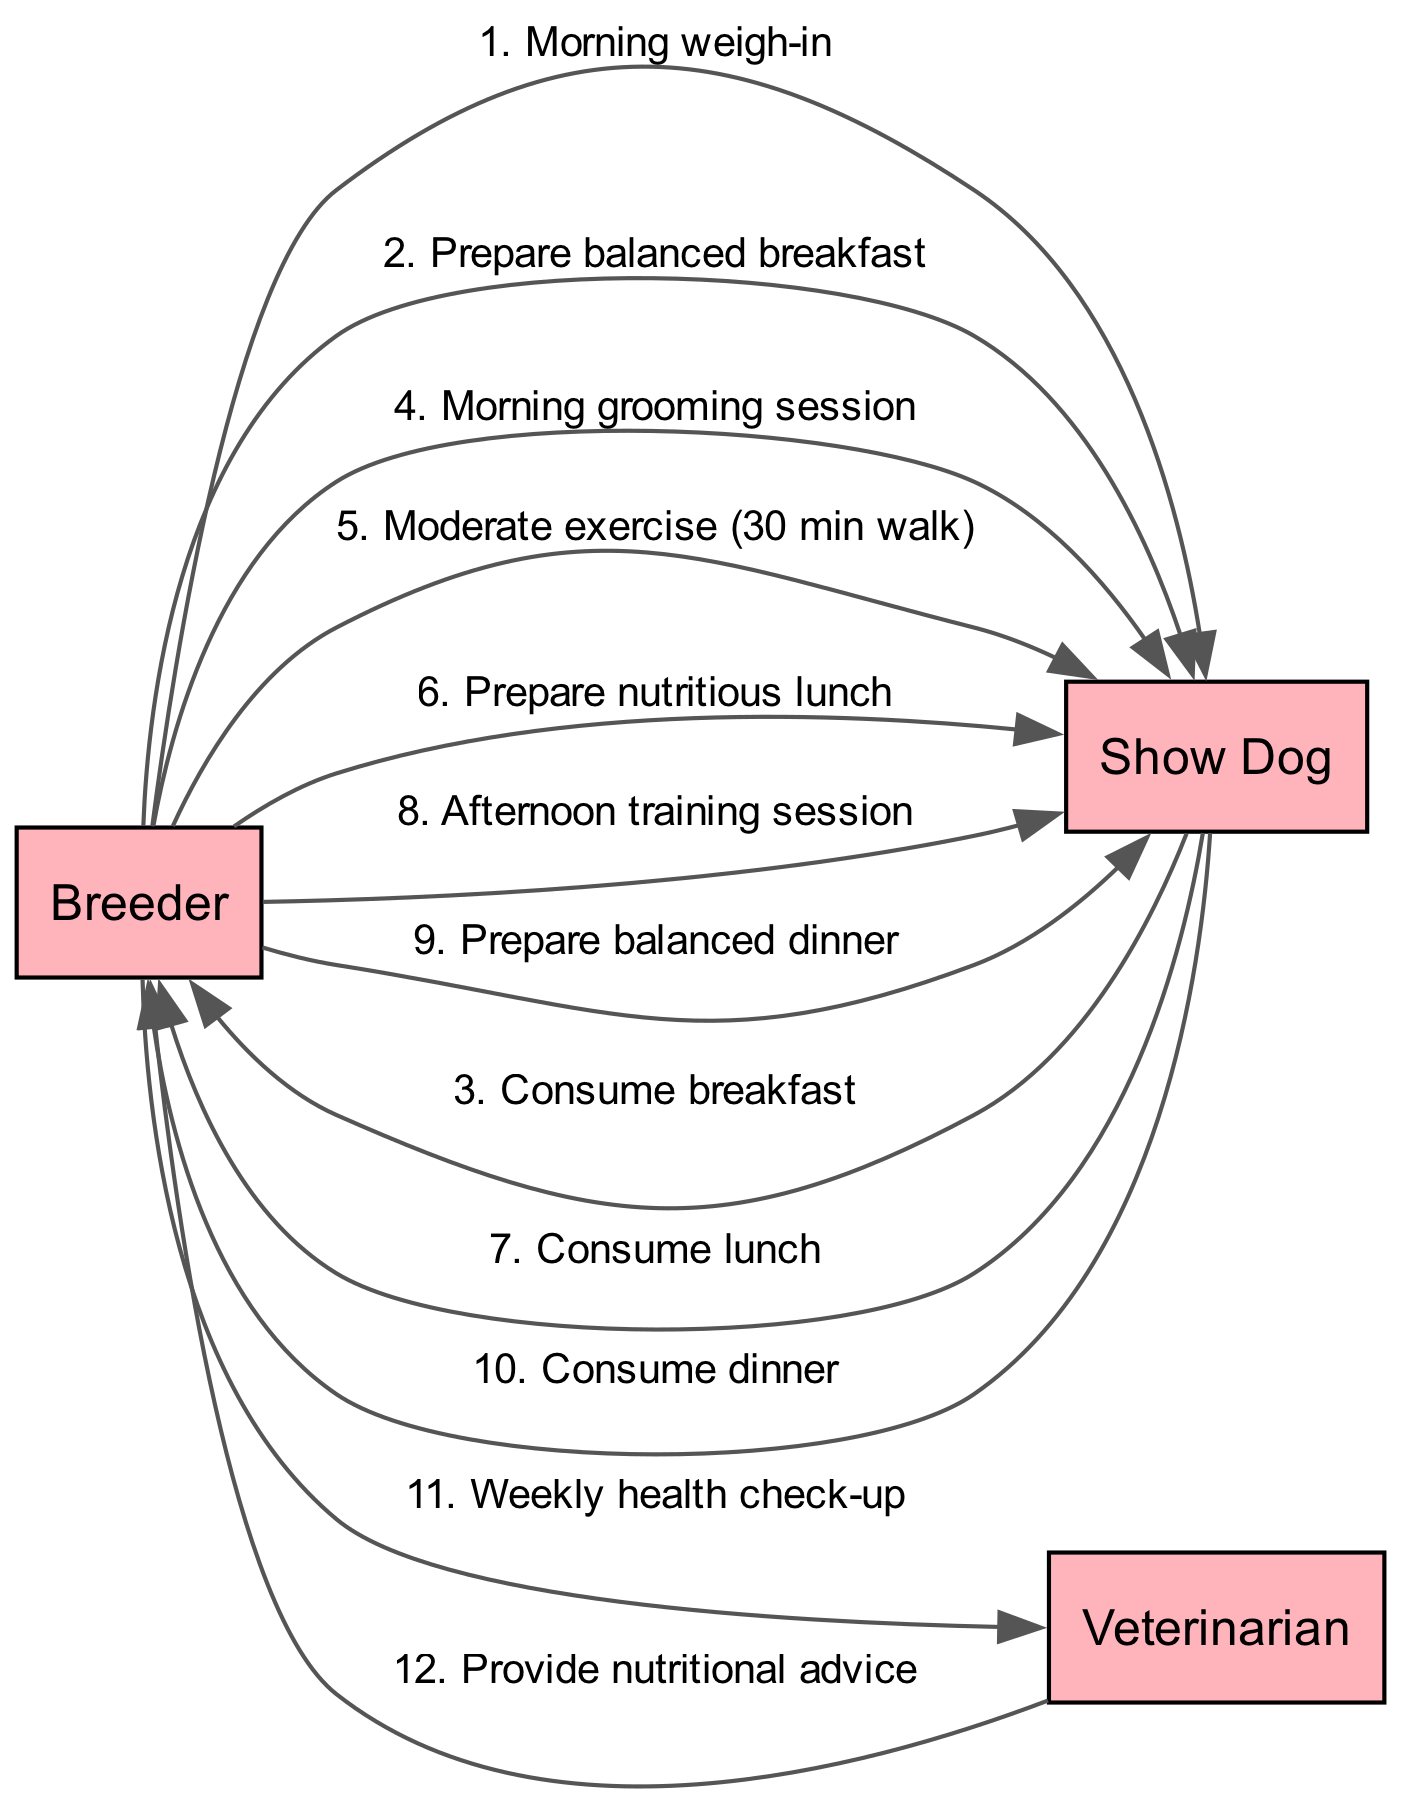What is the first action performed by the breeder? The first action listed in the sequence is "Morning weigh-in," which indicates that the breeder conducts a weigh-in of the show dog in the morning.
Answer: Morning weigh-in How many feeding actions are represented in the diagram? The diagram shows three feeding actions: preparing and consuming breakfast, lunch, and dinner. Each of these actions is represented as interactions between the breeder and the show dog.
Answer: 3 Who does the breeder consult for nutritional advice? The breeder consults the veterinarian for nutritional advice, which is indicated by the connection from the breeder to the veterinarian in the sequence of actions.
Answer: Veterinarian What is the duration of the moderate exercise? The diagram specifies that the duration of the moderate exercise is a "30 min walk," which is explicitly mentioned in the sequence as an action from the breeder to the show dog.
Answer: 30 min Which action follows the consumption of lunch? After the show dog consumes lunch, the next action indicated is the "Afternoon training session," which is a direct continuation in the sequence from the show dog back to the breeder.
Answer: Afternoon training session How many actors are involved in the daily routine? The diagram indicates three actors: the breeder, the show dog, and the veterinarian, who all interact within the context of the sequence of actions.
Answer: 3 What type of session occurs after the morning grooming session? Following the morning grooming session, the next action is a "Moderate exercise (30 min walk)," which directly indicates the type of activity that takes place afterward in the daily routine.
Answer: Moderate exercise What does the veterinarian provide during the weekly health check-up? The veterinarian provides "nutritional advice" during the interaction that occurs after the weekly health check-up conducted by the breeder.
Answer: Nutritional advice 